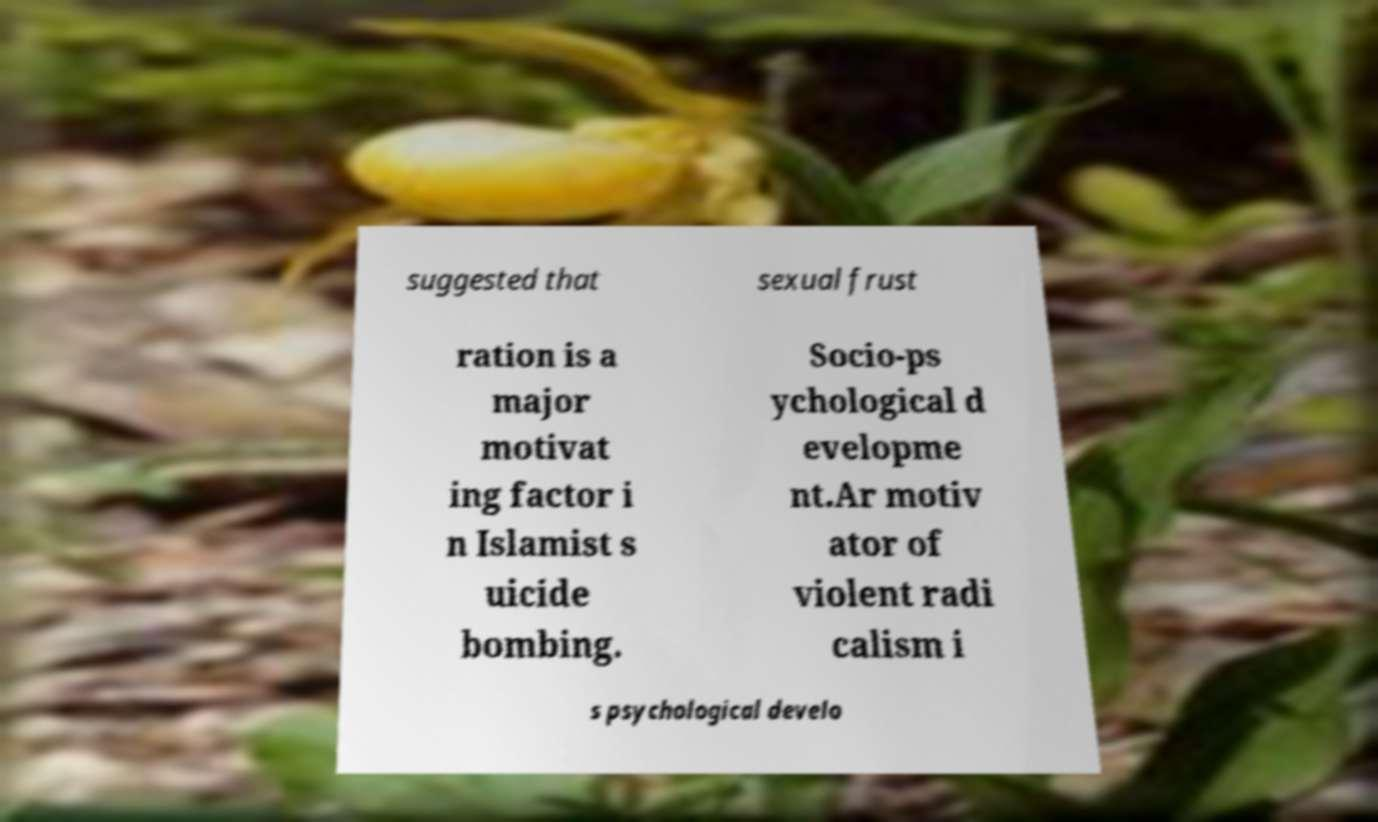Can you read and provide the text displayed in the image?This photo seems to have some interesting text. Can you extract and type it out for me? suggested that sexual frust ration is a major motivat ing factor i n Islamist s uicide bombing. Socio-ps ychological d evelopme nt.Ar motiv ator of violent radi calism i s psychological develo 